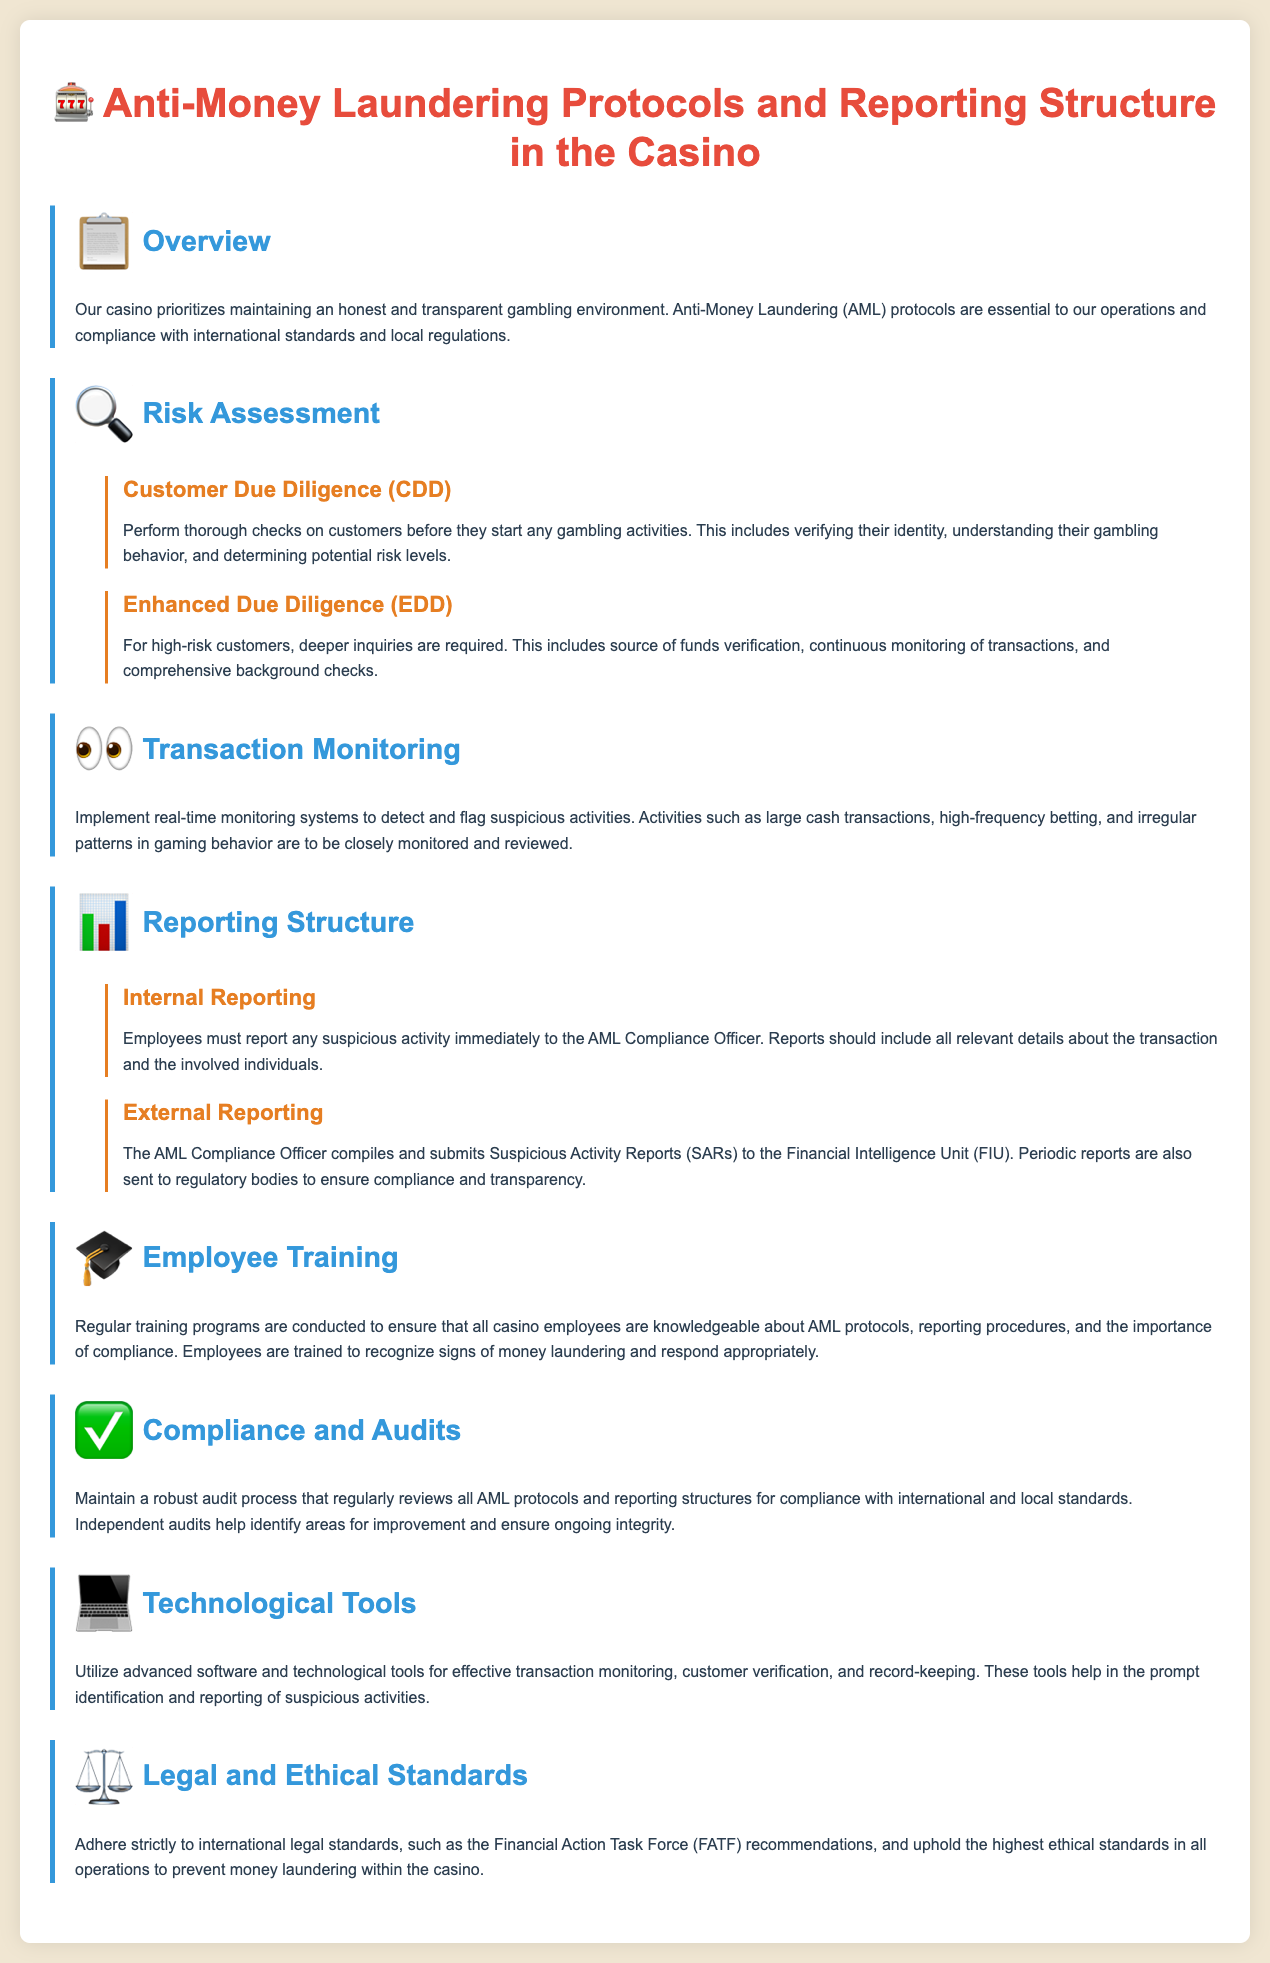What is the primary goal of the casino's AML protocols? The primary goal of the casino's AML protocols is to maintain an honest and transparent gambling environment.
Answer: Honest and transparent gambling environment What are the two types of customer due diligence mentioned? The document mentions Customer Due Diligence (CDD) and Enhanced Due Diligence (EDD).
Answer: CDD and EDD Who should employees report suspicious activities to? Employees must report any suspicious activity immediately to the AML Compliance Officer.
Answer: AML Compliance Officer What does the AML Compliance Officer submit to the Financial Intelligence Unit? The AML Compliance Officer compiles and submits Suspicious Activity Reports (SARs) to the Financial Intelligence Unit.
Answer: Suspicious Activity Reports (SARs) What are casino employees trained to recognize? Employees are trained to recognize signs of money laundering.
Answer: Signs of money laundering What technology is utilized for transaction monitoring? Advanced software and technological tools are utilized for effective transaction monitoring.
Answer: Advanced software and technological tools Which international standards must the casino adhere to? The casino must adhere to international legal standards, such as the Financial Action Task Force (FATF) recommendations.
Answer: Financial Action Task Force (FATF) recommendations What type of audits does the casino maintain? The casino maintains a robust audit process that regularly reviews all AML protocols and reporting structures for compliance.
Answer: Robust audit process What are suspicious activities monitored for? Suspicious activities such as large cash transactions, high-frequency betting, and irregular patterns in gaming behavior are monitored.
Answer: Large cash transactions, high-frequency betting, irregular patterns 